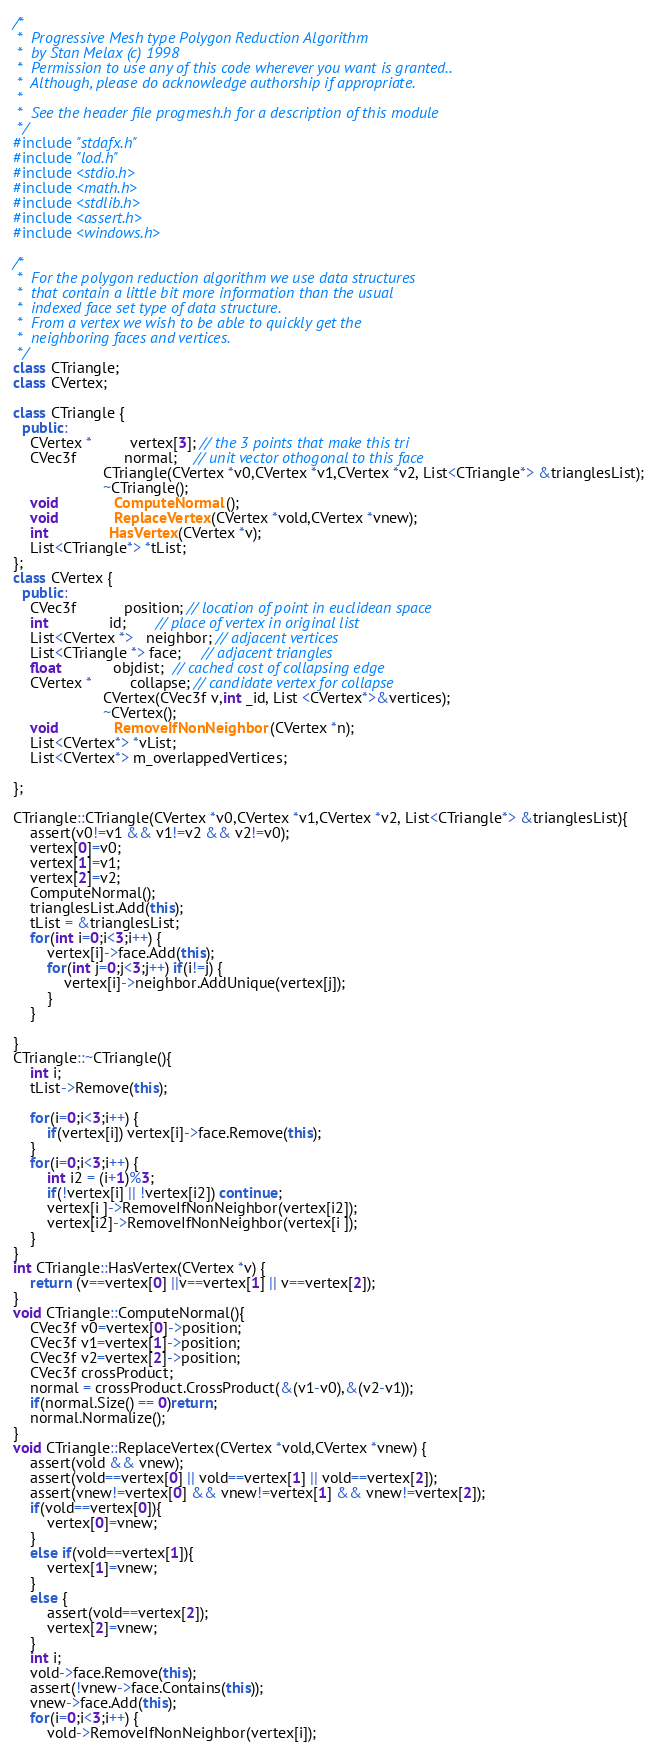<code> <loc_0><loc_0><loc_500><loc_500><_C++_>/*
 *  Progressive Mesh type Polygon Reduction Algorithm
 *  by Stan Melax (c) 1998
 *  Permission to use any of this code wherever you want is granted..
 *  Although, please do acknowledge authorship if appropriate.
 *
 *  See the header file progmesh.h for a description of this module
 */
#include "stdafx.h"
#include "lod.h"
#include <stdio.h>  
#include <math.h>
#include <stdlib.h>
#include <assert.h>
#include <windows.h>

/*
 *  For the polygon reduction algorithm we use data structures
 *  that contain a little bit more information than the usual
 *  indexed face set type of data structure.
 *  From a vertex we wish to be able to quickly get the
 *  neighboring faces and vertices.
 */
class CTriangle;
class CVertex;

class CTriangle {
  public:
	CVertex *         vertex[3]; // the 3 points that make this tri
	CVec3f           normal;    // unit vector othogonal to this face
	                 CTriangle(CVertex *v0,CVertex *v1,CVertex *v2, List<CTriangle*> &trianglesList);
	                 ~CTriangle();
	void             ComputeNormal();
	void             ReplaceVertex(CVertex *vold,CVertex *vnew);
	int              HasVertex(CVertex *v);
	List<CTriangle*> *tList;
};
class CVertex {
  public:
	CVec3f           position; // location of point in euclidean space
	int              id;       // place of vertex in original list
	List<CVertex *>   neighbor; // adjacent vertices
	List<CTriangle *> face;     // adjacent triangles
	float            objdist;  // cached cost of collapsing edge
	CVertex *         collapse; // candidate vertex for collapse
	                 CVertex(CVec3f v,int _id, List <CVertex*>&vertices);
	                 ~CVertex();
	void             RemoveIfNonNeighbor(CVertex *n);
	List<CVertex*> *vList;
	List<CVertex*> m_overlappedVertices;

};

CTriangle::CTriangle(CVertex *v0,CVertex *v1,CVertex *v2, List<CTriangle*> &trianglesList){
	assert(v0!=v1 && v1!=v2 && v2!=v0);
	vertex[0]=v0;
	vertex[1]=v1;
	vertex[2]=v2;
	ComputeNormal();
	trianglesList.Add(this);
	tList = &trianglesList;
	for(int i=0;i<3;i++) {
		vertex[i]->face.Add(this);
		for(int j=0;j<3;j++) if(i!=j) {
			vertex[i]->neighbor.AddUnique(vertex[j]);
		}
	}

}
CTriangle::~CTriangle(){
	int i;
	tList->Remove(this);

	for(i=0;i<3;i++) {
		if(vertex[i]) vertex[i]->face.Remove(this);
	}
	for(i=0;i<3;i++) {
		int i2 = (i+1)%3;
		if(!vertex[i] || !vertex[i2]) continue;
		vertex[i ]->RemoveIfNonNeighbor(vertex[i2]);
		vertex[i2]->RemoveIfNonNeighbor(vertex[i ]);
	}
}
int CTriangle::HasVertex(CVertex *v) {
	return (v==vertex[0] ||v==vertex[1] || v==vertex[2]);
}
void CTriangle::ComputeNormal(){
	CVec3f v0=vertex[0]->position;
	CVec3f v1=vertex[1]->position;
	CVec3f v2=vertex[2]->position;
	CVec3f crossProduct;
	normal = crossProduct.CrossProduct(&(v1-v0),&(v2-v1));
	if(normal.Size() == 0)return;
	normal.Normalize();
}
void CTriangle::ReplaceVertex(CVertex *vold,CVertex *vnew) {
	assert(vold && vnew);
	assert(vold==vertex[0] || vold==vertex[1] || vold==vertex[2]);
	assert(vnew!=vertex[0] && vnew!=vertex[1] && vnew!=vertex[2]);
	if(vold==vertex[0]){
		vertex[0]=vnew;
	}
	else if(vold==vertex[1]){
		vertex[1]=vnew;
	}
	else {
		assert(vold==vertex[2]);
		vertex[2]=vnew;
	}
	int i;
	vold->face.Remove(this);
	assert(!vnew->face.Contains(this));
	vnew->face.Add(this);
	for(i=0;i<3;i++) {
		vold->RemoveIfNonNeighbor(vertex[i]);</code> 